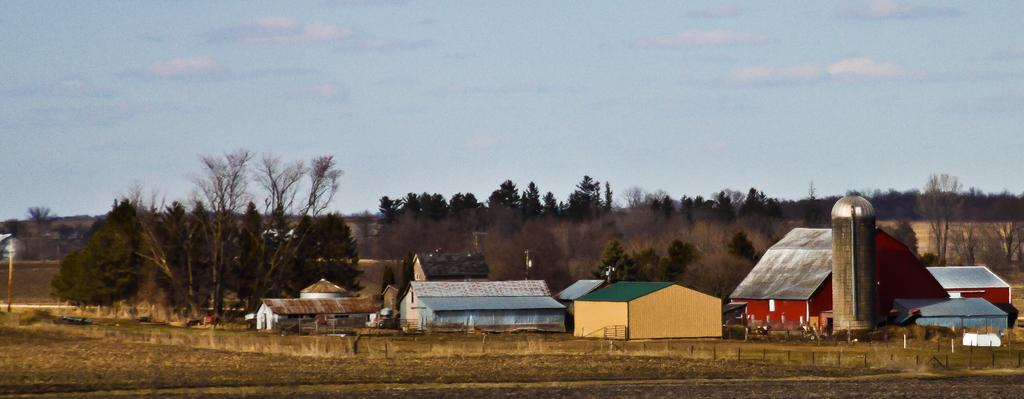What structures are located in the center of the image? There are sheds in the center of the image. What can be seen on the right side of the image? There is a water tower on the right side of the image. What type of vegetation is visible in the background of the image? There are trees in the background of the image. What is visible in the background of the image besides the trees? The sky is visible in the background of the image. Which leg is the water tower standing on in the image? The water tower is not a living being and does not have legs. It is a stationary structure supported by its base. What does the mouth of the water tower look like in the image? The water tower is an inanimate object and does not have a mouth. 